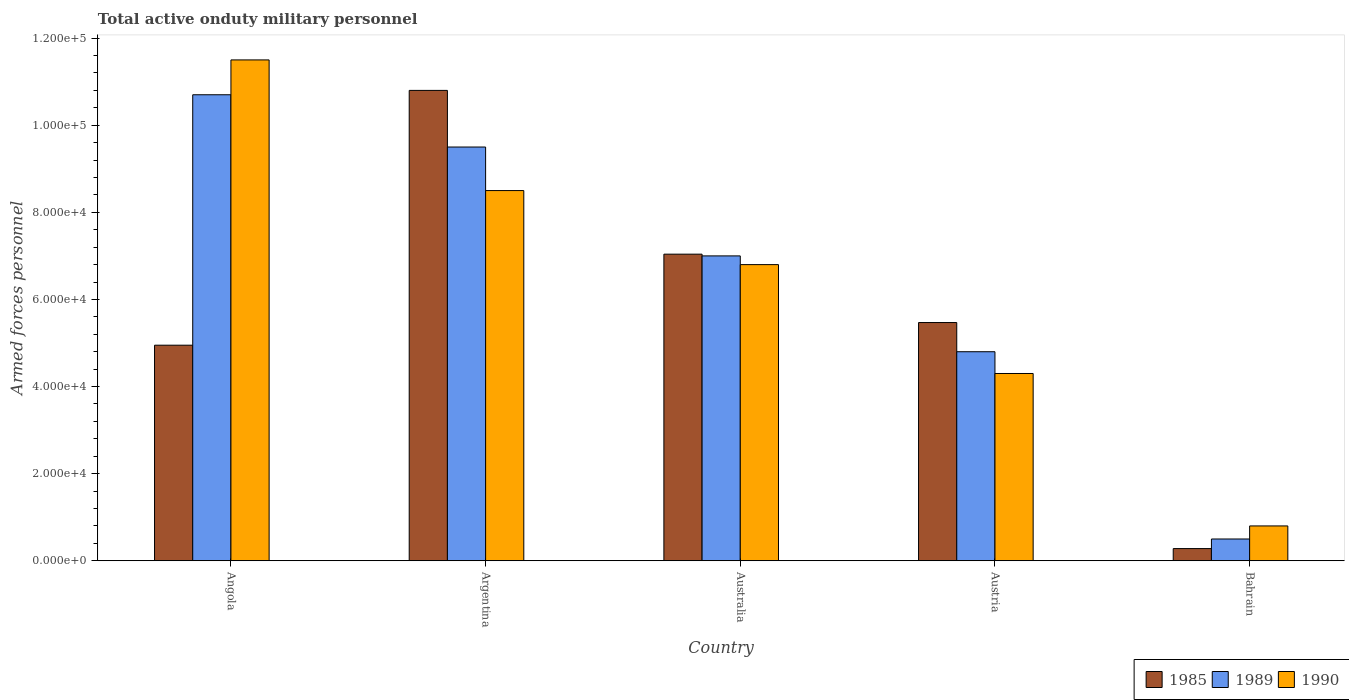How many different coloured bars are there?
Make the answer very short. 3. How many groups of bars are there?
Give a very brief answer. 5. How many bars are there on the 1st tick from the left?
Your answer should be very brief. 3. How many bars are there on the 2nd tick from the right?
Ensure brevity in your answer.  3. What is the label of the 3rd group of bars from the left?
Offer a terse response. Australia. What is the number of armed forces personnel in 1989 in Argentina?
Offer a terse response. 9.50e+04. Across all countries, what is the maximum number of armed forces personnel in 1990?
Your answer should be very brief. 1.15e+05. Across all countries, what is the minimum number of armed forces personnel in 1990?
Give a very brief answer. 8000. In which country was the number of armed forces personnel in 1985 maximum?
Make the answer very short. Argentina. In which country was the number of armed forces personnel in 1985 minimum?
Your response must be concise. Bahrain. What is the total number of armed forces personnel in 1990 in the graph?
Provide a short and direct response. 3.19e+05. What is the difference between the number of armed forces personnel in 1990 in Angola and that in Austria?
Provide a short and direct response. 7.20e+04. What is the difference between the number of armed forces personnel in 1990 in Bahrain and the number of armed forces personnel in 1989 in Australia?
Offer a terse response. -6.20e+04. What is the average number of armed forces personnel in 1990 per country?
Your answer should be very brief. 6.38e+04. What is the difference between the number of armed forces personnel of/in 1990 and number of armed forces personnel of/in 1985 in Angola?
Give a very brief answer. 6.55e+04. In how many countries, is the number of armed forces personnel in 1985 greater than 92000?
Your answer should be very brief. 1. What is the ratio of the number of armed forces personnel in 1990 in Australia to that in Austria?
Keep it short and to the point. 1.58. Is the number of armed forces personnel in 1985 in Australia less than that in Bahrain?
Offer a very short reply. No. What is the difference between the highest and the second highest number of armed forces personnel in 1985?
Provide a short and direct response. 3.76e+04. What is the difference between the highest and the lowest number of armed forces personnel in 1990?
Keep it short and to the point. 1.07e+05. In how many countries, is the number of armed forces personnel in 1990 greater than the average number of armed forces personnel in 1990 taken over all countries?
Make the answer very short. 3. Is the sum of the number of armed forces personnel in 1990 in Angola and Australia greater than the maximum number of armed forces personnel in 1989 across all countries?
Your answer should be very brief. Yes. What does the 2nd bar from the right in Austria represents?
Offer a terse response. 1989. Is it the case that in every country, the sum of the number of armed forces personnel in 1985 and number of armed forces personnel in 1989 is greater than the number of armed forces personnel in 1990?
Offer a terse response. No. Are all the bars in the graph horizontal?
Ensure brevity in your answer.  No. What is the difference between two consecutive major ticks on the Y-axis?
Ensure brevity in your answer.  2.00e+04. Are the values on the major ticks of Y-axis written in scientific E-notation?
Your answer should be very brief. Yes. What is the title of the graph?
Your response must be concise. Total active onduty military personnel. What is the label or title of the Y-axis?
Keep it short and to the point. Armed forces personnel. What is the Armed forces personnel of 1985 in Angola?
Give a very brief answer. 4.95e+04. What is the Armed forces personnel of 1989 in Angola?
Keep it short and to the point. 1.07e+05. What is the Armed forces personnel of 1990 in Angola?
Ensure brevity in your answer.  1.15e+05. What is the Armed forces personnel of 1985 in Argentina?
Provide a short and direct response. 1.08e+05. What is the Armed forces personnel of 1989 in Argentina?
Your answer should be compact. 9.50e+04. What is the Armed forces personnel in 1990 in Argentina?
Keep it short and to the point. 8.50e+04. What is the Armed forces personnel in 1985 in Australia?
Give a very brief answer. 7.04e+04. What is the Armed forces personnel of 1989 in Australia?
Your answer should be compact. 7.00e+04. What is the Armed forces personnel in 1990 in Australia?
Your answer should be very brief. 6.80e+04. What is the Armed forces personnel in 1985 in Austria?
Keep it short and to the point. 5.47e+04. What is the Armed forces personnel in 1989 in Austria?
Make the answer very short. 4.80e+04. What is the Armed forces personnel of 1990 in Austria?
Keep it short and to the point. 4.30e+04. What is the Armed forces personnel in 1985 in Bahrain?
Your answer should be very brief. 2800. What is the Armed forces personnel of 1990 in Bahrain?
Provide a short and direct response. 8000. Across all countries, what is the maximum Armed forces personnel in 1985?
Your response must be concise. 1.08e+05. Across all countries, what is the maximum Armed forces personnel in 1989?
Make the answer very short. 1.07e+05. Across all countries, what is the maximum Armed forces personnel of 1990?
Provide a short and direct response. 1.15e+05. Across all countries, what is the minimum Armed forces personnel in 1985?
Your response must be concise. 2800. Across all countries, what is the minimum Armed forces personnel in 1990?
Offer a terse response. 8000. What is the total Armed forces personnel of 1985 in the graph?
Ensure brevity in your answer.  2.85e+05. What is the total Armed forces personnel of 1989 in the graph?
Ensure brevity in your answer.  3.25e+05. What is the total Armed forces personnel in 1990 in the graph?
Give a very brief answer. 3.19e+05. What is the difference between the Armed forces personnel of 1985 in Angola and that in Argentina?
Make the answer very short. -5.85e+04. What is the difference between the Armed forces personnel in 1989 in Angola and that in Argentina?
Offer a terse response. 1.20e+04. What is the difference between the Armed forces personnel of 1985 in Angola and that in Australia?
Provide a short and direct response. -2.09e+04. What is the difference between the Armed forces personnel of 1989 in Angola and that in Australia?
Offer a terse response. 3.70e+04. What is the difference between the Armed forces personnel in 1990 in Angola and that in Australia?
Your answer should be very brief. 4.70e+04. What is the difference between the Armed forces personnel in 1985 in Angola and that in Austria?
Your response must be concise. -5200. What is the difference between the Armed forces personnel of 1989 in Angola and that in Austria?
Ensure brevity in your answer.  5.90e+04. What is the difference between the Armed forces personnel of 1990 in Angola and that in Austria?
Keep it short and to the point. 7.20e+04. What is the difference between the Armed forces personnel of 1985 in Angola and that in Bahrain?
Ensure brevity in your answer.  4.67e+04. What is the difference between the Armed forces personnel in 1989 in Angola and that in Bahrain?
Your answer should be compact. 1.02e+05. What is the difference between the Armed forces personnel in 1990 in Angola and that in Bahrain?
Give a very brief answer. 1.07e+05. What is the difference between the Armed forces personnel in 1985 in Argentina and that in Australia?
Ensure brevity in your answer.  3.76e+04. What is the difference between the Armed forces personnel in 1989 in Argentina and that in Australia?
Your response must be concise. 2.50e+04. What is the difference between the Armed forces personnel of 1990 in Argentina and that in Australia?
Offer a very short reply. 1.70e+04. What is the difference between the Armed forces personnel in 1985 in Argentina and that in Austria?
Offer a terse response. 5.33e+04. What is the difference between the Armed forces personnel of 1989 in Argentina and that in Austria?
Your answer should be compact. 4.70e+04. What is the difference between the Armed forces personnel of 1990 in Argentina and that in Austria?
Make the answer very short. 4.20e+04. What is the difference between the Armed forces personnel in 1985 in Argentina and that in Bahrain?
Your answer should be compact. 1.05e+05. What is the difference between the Armed forces personnel in 1989 in Argentina and that in Bahrain?
Your response must be concise. 9.00e+04. What is the difference between the Armed forces personnel of 1990 in Argentina and that in Bahrain?
Your response must be concise. 7.70e+04. What is the difference between the Armed forces personnel in 1985 in Australia and that in Austria?
Make the answer very short. 1.57e+04. What is the difference between the Armed forces personnel of 1989 in Australia and that in Austria?
Make the answer very short. 2.20e+04. What is the difference between the Armed forces personnel in 1990 in Australia and that in Austria?
Your response must be concise. 2.50e+04. What is the difference between the Armed forces personnel of 1985 in Australia and that in Bahrain?
Provide a short and direct response. 6.76e+04. What is the difference between the Armed forces personnel in 1989 in Australia and that in Bahrain?
Give a very brief answer. 6.50e+04. What is the difference between the Armed forces personnel of 1985 in Austria and that in Bahrain?
Your answer should be compact. 5.19e+04. What is the difference between the Armed forces personnel in 1989 in Austria and that in Bahrain?
Offer a very short reply. 4.30e+04. What is the difference between the Armed forces personnel in 1990 in Austria and that in Bahrain?
Provide a succinct answer. 3.50e+04. What is the difference between the Armed forces personnel of 1985 in Angola and the Armed forces personnel of 1989 in Argentina?
Offer a terse response. -4.55e+04. What is the difference between the Armed forces personnel in 1985 in Angola and the Armed forces personnel in 1990 in Argentina?
Give a very brief answer. -3.55e+04. What is the difference between the Armed forces personnel of 1989 in Angola and the Armed forces personnel of 1990 in Argentina?
Ensure brevity in your answer.  2.20e+04. What is the difference between the Armed forces personnel in 1985 in Angola and the Armed forces personnel in 1989 in Australia?
Provide a succinct answer. -2.05e+04. What is the difference between the Armed forces personnel in 1985 in Angola and the Armed forces personnel in 1990 in Australia?
Make the answer very short. -1.85e+04. What is the difference between the Armed forces personnel of 1989 in Angola and the Armed forces personnel of 1990 in Australia?
Your response must be concise. 3.90e+04. What is the difference between the Armed forces personnel in 1985 in Angola and the Armed forces personnel in 1989 in Austria?
Offer a very short reply. 1500. What is the difference between the Armed forces personnel of 1985 in Angola and the Armed forces personnel of 1990 in Austria?
Give a very brief answer. 6500. What is the difference between the Armed forces personnel in 1989 in Angola and the Armed forces personnel in 1990 in Austria?
Give a very brief answer. 6.40e+04. What is the difference between the Armed forces personnel in 1985 in Angola and the Armed forces personnel in 1989 in Bahrain?
Your answer should be very brief. 4.45e+04. What is the difference between the Armed forces personnel of 1985 in Angola and the Armed forces personnel of 1990 in Bahrain?
Give a very brief answer. 4.15e+04. What is the difference between the Armed forces personnel of 1989 in Angola and the Armed forces personnel of 1990 in Bahrain?
Provide a short and direct response. 9.90e+04. What is the difference between the Armed forces personnel of 1985 in Argentina and the Armed forces personnel of 1989 in Australia?
Offer a very short reply. 3.80e+04. What is the difference between the Armed forces personnel of 1985 in Argentina and the Armed forces personnel of 1990 in Australia?
Your response must be concise. 4.00e+04. What is the difference between the Armed forces personnel in 1989 in Argentina and the Armed forces personnel in 1990 in Australia?
Ensure brevity in your answer.  2.70e+04. What is the difference between the Armed forces personnel of 1985 in Argentina and the Armed forces personnel of 1989 in Austria?
Your answer should be compact. 6.00e+04. What is the difference between the Armed forces personnel in 1985 in Argentina and the Armed forces personnel in 1990 in Austria?
Ensure brevity in your answer.  6.50e+04. What is the difference between the Armed forces personnel in 1989 in Argentina and the Armed forces personnel in 1990 in Austria?
Offer a terse response. 5.20e+04. What is the difference between the Armed forces personnel of 1985 in Argentina and the Armed forces personnel of 1989 in Bahrain?
Your answer should be very brief. 1.03e+05. What is the difference between the Armed forces personnel in 1985 in Argentina and the Armed forces personnel in 1990 in Bahrain?
Provide a short and direct response. 1.00e+05. What is the difference between the Armed forces personnel in 1989 in Argentina and the Armed forces personnel in 1990 in Bahrain?
Provide a succinct answer. 8.70e+04. What is the difference between the Armed forces personnel in 1985 in Australia and the Armed forces personnel in 1989 in Austria?
Your response must be concise. 2.24e+04. What is the difference between the Armed forces personnel in 1985 in Australia and the Armed forces personnel in 1990 in Austria?
Your answer should be very brief. 2.74e+04. What is the difference between the Armed forces personnel in 1989 in Australia and the Armed forces personnel in 1990 in Austria?
Your response must be concise. 2.70e+04. What is the difference between the Armed forces personnel in 1985 in Australia and the Armed forces personnel in 1989 in Bahrain?
Provide a short and direct response. 6.54e+04. What is the difference between the Armed forces personnel of 1985 in Australia and the Armed forces personnel of 1990 in Bahrain?
Give a very brief answer. 6.24e+04. What is the difference between the Armed forces personnel of 1989 in Australia and the Armed forces personnel of 1990 in Bahrain?
Your answer should be compact. 6.20e+04. What is the difference between the Armed forces personnel of 1985 in Austria and the Armed forces personnel of 1989 in Bahrain?
Ensure brevity in your answer.  4.97e+04. What is the difference between the Armed forces personnel in 1985 in Austria and the Armed forces personnel in 1990 in Bahrain?
Provide a short and direct response. 4.67e+04. What is the average Armed forces personnel in 1985 per country?
Give a very brief answer. 5.71e+04. What is the average Armed forces personnel of 1989 per country?
Make the answer very short. 6.50e+04. What is the average Armed forces personnel of 1990 per country?
Your answer should be compact. 6.38e+04. What is the difference between the Armed forces personnel of 1985 and Armed forces personnel of 1989 in Angola?
Your answer should be very brief. -5.75e+04. What is the difference between the Armed forces personnel in 1985 and Armed forces personnel in 1990 in Angola?
Provide a short and direct response. -6.55e+04. What is the difference between the Armed forces personnel in 1989 and Armed forces personnel in 1990 in Angola?
Ensure brevity in your answer.  -8000. What is the difference between the Armed forces personnel in 1985 and Armed forces personnel in 1989 in Argentina?
Give a very brief answer. 1.30e+04. What is the difference between the Armed forces personnel in 1985 and Armed forces personnel in 1990 in Argentina?
Your response must be concise. 2.30e+04. What is the difference between the Armed forces personnel of 1989 and Armed forces personnel of 1990 in Argentina?
Provide a short and direct response. 10000. What is the difference between the Armed forces personnel in 1985 and Armed forces personnel in 1989 in Australia?
Provide a short and direct response. 400. What is the difference between the Armed forces personnel in 1985 and Armed forces personnel in 1990 in Australia?
Offer a very short reply. 2400. What is the difference between the Armed forces personnel in 1989 and Armed forces personnel in 1990 in Australia?
Your answer should be compact. 2000. What is the difference between the Armed forces personnel in 1985 and Armed forces personnel in 1989 in Austria?
Your answer should be compact. 6700. What is the difference between the Armed forces personnel of 1985 and Armed forces personnel of 1990 in Austria?
Give a very brief answer. 1.17e+04. What is the difference between the Armed forces personnel of 1989 and Armed forces personnel of 1990 in Austria?
Your answer should be very brief. 5000. What is the difference between the Armed forces personnel of 1985 and Armed forces personnel of 1989 in Bahrain?
Make the answer very short. -2200. What is the difference between the Armed forces personnel of 1985 and Armed forces personnel of 1990 in Bahrain?
Your response must be concise. -5200. What is the difference between the Armed forces personnel in 1989 and Armed forces personnel in 1990 in Bahrain?
Your answer should be very brief. -3000. What is the ratio of the Armed forces personnel in 1985 in Angola to that in Argentina?
Your answer should be very brief. 0.46. What is the ratio of the Armed forces personnel of 1989 in Angola to that in Argentina?
Provide a short and direct response. 1.13. What is the ratio of the Armed forces personnel of 1990 in Angola to that in Argentina?
Ensure brevity in your answer.  1.35. What is the ratio of the Armed forces personnel in 1985 in Angola to that in Australia?
Your response must be concise. 0.7. What is the ratio of the Armed forces personnel of 1989 in Angola to that in Australia?
Ensure brevity in your answer.  1.53. What is the ratio of the Armed forces personnel of 1990 in Angola to that in Australia?
Your answer should be compact. 1.69. What is the ratio of the Armed forces personnel of 1985 in Angola to that in Austria?
Offer a very short reply. 0.9. What is the ratio of the Armed forces personnel of 1989 in Angola to that in Austria?
Offer a very short reply. 2.23. What is the ratio of the Armed forces personnel in 1990 in Angola to that in Austria?
Offer a terse response. 2.67. What is the ratio of the Armed forces personnel of 1985 in Angola to that in Bahrain?
Provide a succinct answer. 17.68. What is the ratio of the Armed forces personnel in 1989 in Angola to that in Bahrain?
Offer a very short reply. 21.4. What is the ratio of the Armed forces personnel of 1990 in Angola to that in Bahrain?
Give a very brief answer. 14.38. What is the ratio of the Armed forces personnel of 1985 in Argentina to that in Australia?
Provide a short and direct response. 1.53. What is the ratio of the Armed forces personnel of 1989 in Argentina to that in Australia?
Keep it short and to the point. 1.36. What is the ratio of the Armed forces personnel of 1985 in Argentina to that in Austria?
Offer a terse response. 1.97. What is the ratio of the Armed forces personnel of 1989 in Argentina to that in Austria?
Give a very brief answer. 1.98. What is the ratio of the Armed forces personnel of 1990 in Argentina to that in Austria?
Your answer should be compact. 1.98. What is the ratio of the Armed forces personnel of 1985 in Argentina to that in Bahrain?
Offer a terse response. 38.57. What is the ratio of the Armed forces personnel of 1990 in Argentina to that in Bahrain?
Give a very brief answer. 10.62. What is the ratio of the Armed forces personnel of 1985 in Australia to that in Austria?
Make the answer very short. 1.29. What is the ratio of the Armed forces personnel of 1989 in Australia to that in Austria?
Provide a succinct answer. 1.46. What is the ratio of the Armed forces personnel in 1990 in Australia to that in Austria?
Provide a short and direct response. 1.58. What is the ratio of the Armed forces personnel in 1985 in Australia to that in Bahrain?
Keep it short and to the point. 25.14. What is the ratio of the Armed forces personnel of 1989 in Australia to that in Bahrain?
Offer a very short reply. 14. What is the ratio of the Armed forces personnel of 1990 in Australia to that in Bahrain?
Your response must be concise. 8.5. What is the ratio of the Armed forces personnel in 1985 in Austria to that in Bahrain?
Provide a short and direct response. 19.54. What is the ratio of the Armed forces personnel of 1989 in Austria to that in Bahrain?
Make the answer very short. 9.6. What is the ratio of the Armed forces personnel of 1990 in Austria to that in Bahrain?
Your answer should be compact. 5.38. What is the difference between the highest and the second highest Armed forces personnel in 1985?
Your response must be concise. 3.76e+04. What is the difference between the highest and the second highest Armed forces personnel of 1989?
Offer a terse response. 1.20e+04. What is the difference between the highest and the lowest Armed forces personnel in 1985?
Provide a succinct answer. 1.05e+05. What is the difference between the highest and the lowest Armed forces personnel in 1989?
Your answer should be very brief. 1.02e+05. What is the difference between the highest and the lowest Armed forces personnel in 1990?
Your answer should be very brief. 1.07e+05. 